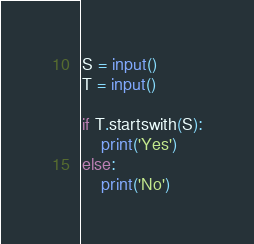Convert code to text. <code><loc_0><loc_0><loc_500><loc_500><_Python_>S = input()
T = input()

if T.startswith(S):
    print('Yes')
else:
    print('No')</code> 